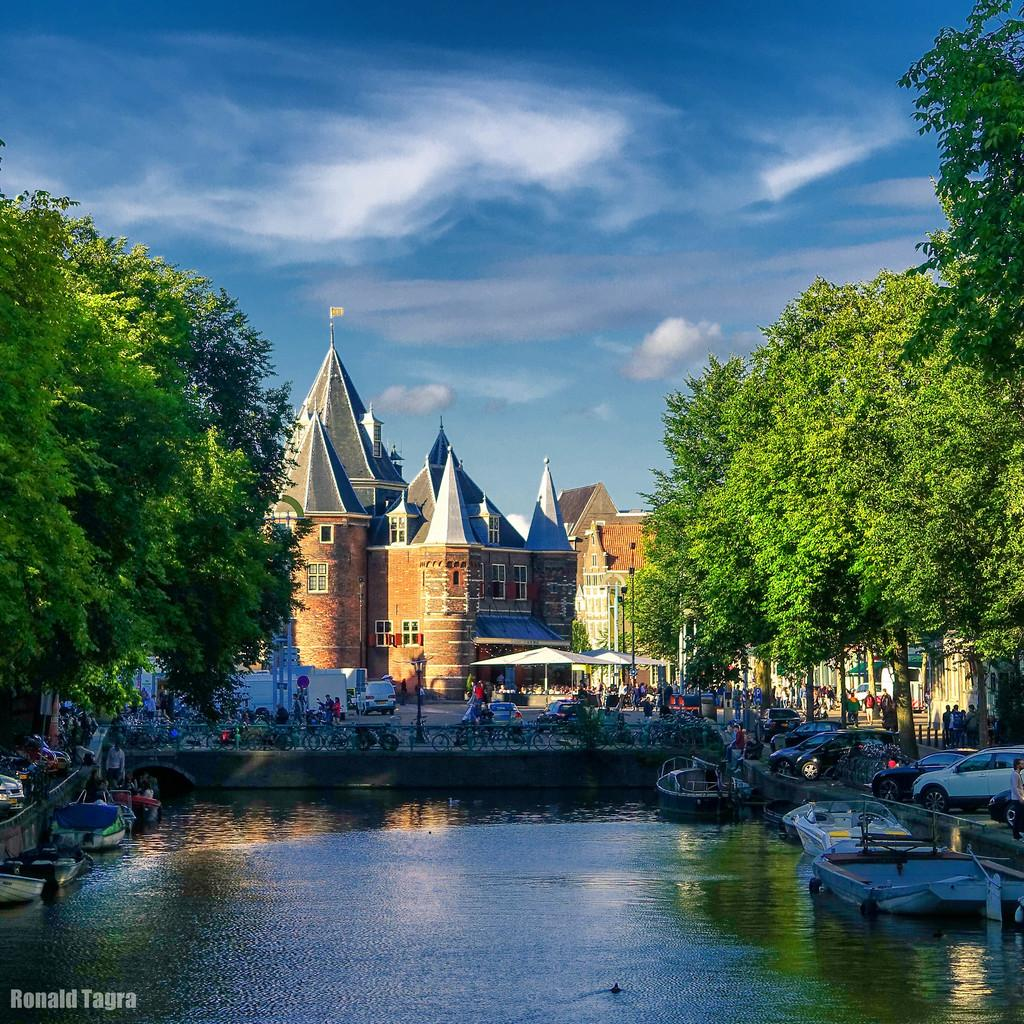What type of structures are present in the image? There are castles in the image. What type of natural elements can be seen in the image? There are trees in the image. What type of barrier is visible in the image? There is a fence in the image. What type of transportation can be seen in the image? There are vehicles in the image. What type of watercraft can be seen in the image? There are boats in the image. What type of terrain is visible in the image? There is water visible in the image. Are there any living beings present in the image? Yes, there are people in the image. What part of the natural environment is visible in the image? The sky is visible in the image. Where is the jewel hidden in the image? There is no mention of a jewel in the image, so it cannot be determined where it might be hidden. What type of drainage system is visible in the image? There is no mention of a drainage system in the image, so it cannot be determined if one is visible. 